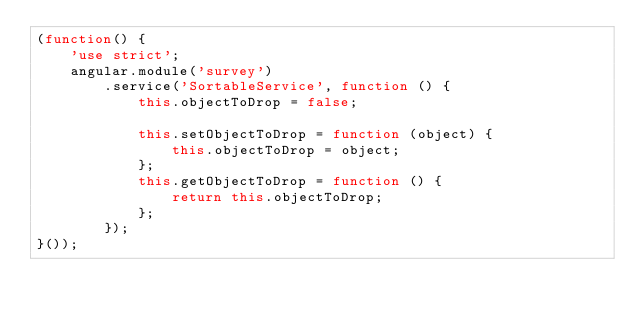Convert code to text. <code><loc_0><loc_0><loc_500><loc_500><_JavaScript_>(function() {
    'use strict';
    angular.module('survey')
        .service('SortableService', function () {
            this.objectToDrop = false;

            this.setObjectToDrop = function (object) {
                this.objectToDrop = object;
            };
            this.getObjectToDrop = function () {
                return this.objectToDrop;
            };
        });
}());</code> 